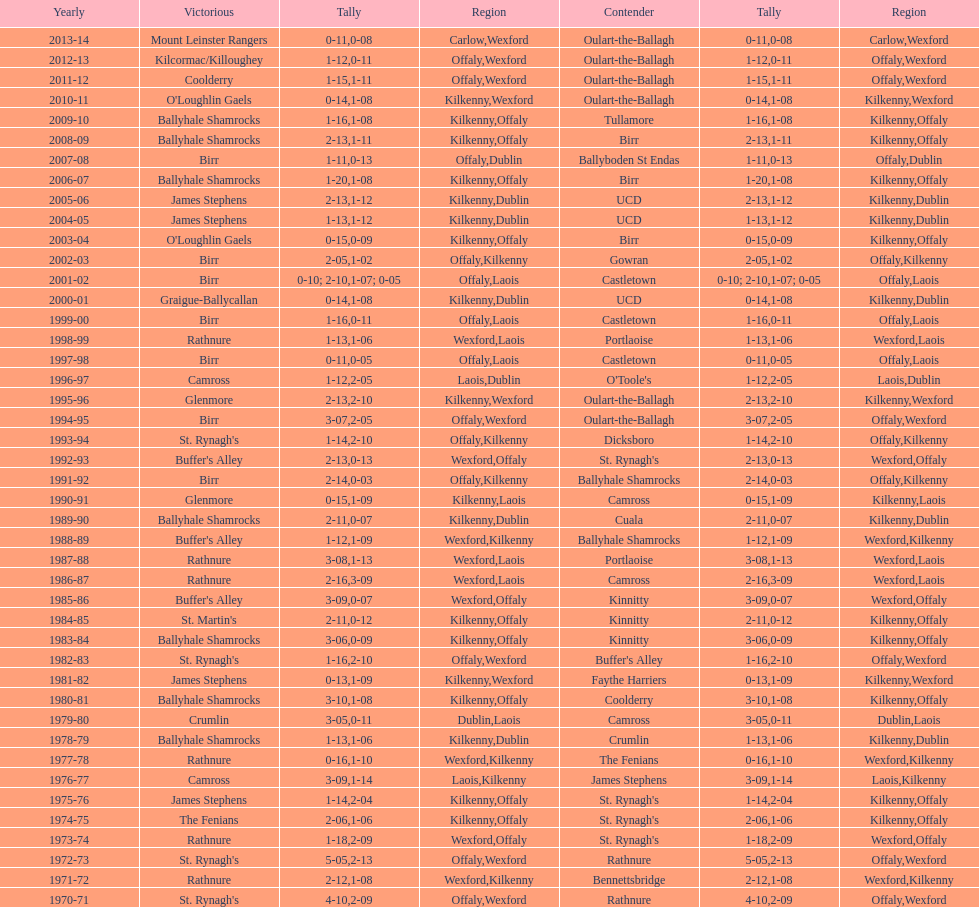In what most recent season was the leinster senior club hurling championships decided by a point difference of under 11? 2007-08. 